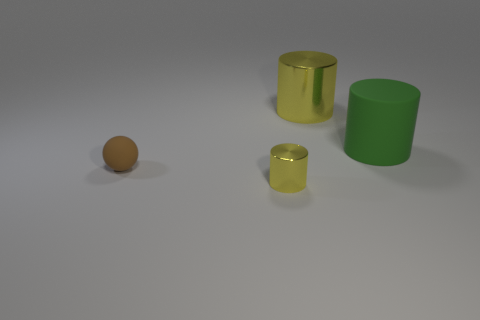There is a sphere; does it have the same size as the matte thing on the right side of the tiny yellow thing?
Offer a very short reply. No. How many matte objects are brown objects or tiny yellow cylinders?
Make the answer very short. 1. How many other yellow objects are the same shape as the tiny yellow metallic thing?
Your answer should be very brief. 1. What is the material of the other cylinder that is the same color as the small metal cylinder?
Your response must be concise. Metal. There is a metallic cylinder that is on the right side of the small shiny thing; is its size the same as the yellow shiny thing that is in front of the sphere?
Offer a terse response. No. The matte thing that is in front of the green thing has what shape?
Ensure brevity in your answer.  Sphere. There is a tiny object that is the same shape as the big green matte thing; what material is it?
Offer a terse response. Metal. Is the size of the rubber thing that is in front of the green cylinder the same as the small yellow cylinder?
Your response must be concise. Yes. How many things are to the right of the tiny matte thing?
Keep it short and to the point. 3. Are there fewer brown matte objects in front of the large green matte thing than tiny rubber spheres that are to the right of the small shiny cylinder?
Your answer should be very brief. No. 